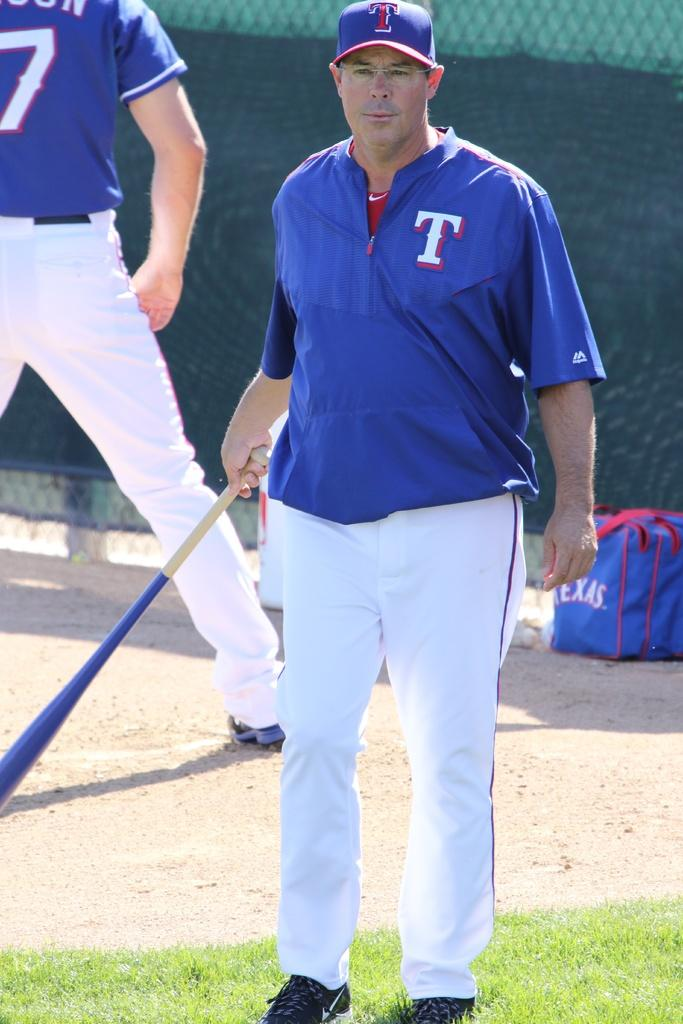<image>
Relay a brief, clear account of the picture shown. A baseball player with bat in hand wearing a blue shirt with a T on left shoulder and white pants. 